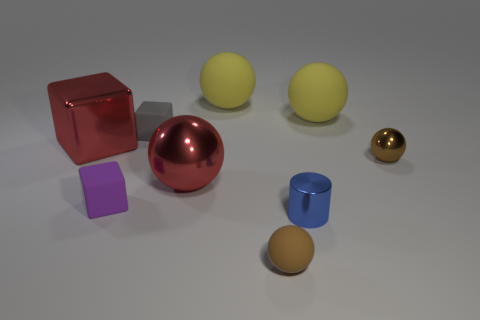What is the material of the other sphere that is the same color as the small metal sphere?
Provide a short and direct response. Rubber. The other ball that is the same color as the small matte sphere is what size?
Keep it short and to the point. Small. Are there any large metallic spheres?
Make the answer very short. Yes. What shape is the blue object that is made of the same material as the red ball?
Offer a terse response. Cylinder. Is the shape of the purple rubber thing the same as the brown thing that is in front of the brown metallic sphere?
Your response must be concise. No. There is a yellow ball left of the small brown sphere in front of the cylinder; what is its material?
Offer a terse response. Rubber. How many other objects are there of the same shape as the blue shiny object?
Provide a succinct answer. 0. Do the tiny object that is on the left side of the gray rubber block and the red metallic thing behind the brown shiny thing have the same shape?
Provide a short and direct response. Yes. Are there any other things that are the same material as the purple thing?
Give a very brief answer. Yes. What is the material of the small cylinder?
Keep it short and to the point. Metal. 